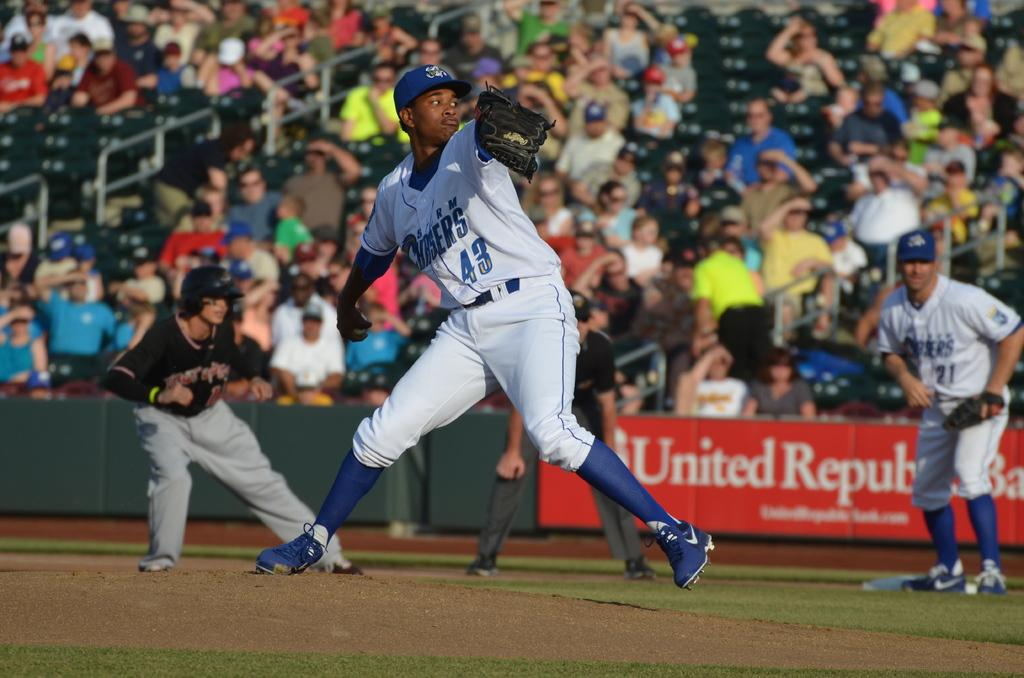<image>
Create a compact narrative representing the image presented. A baseball player wearing a storm chasers uniform is getting ready to pitch the ball. 